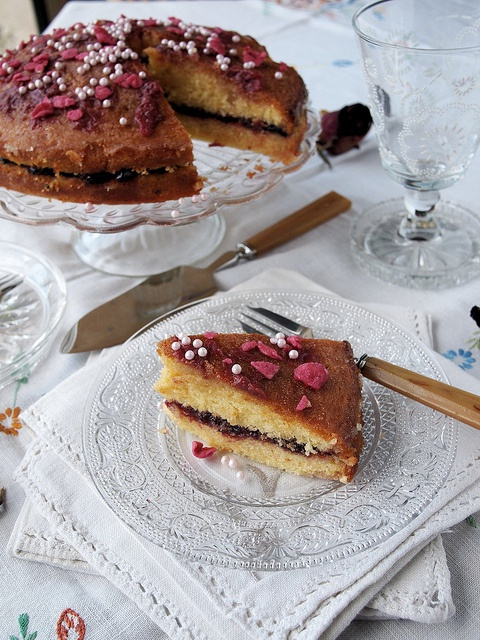Describe the objects in this image and their specific colors. I can see dining table in lightgray, darkgray, maroon, and gray tones, cake in lightgray, maroon, black, and brown tones, wine glass in lightgray and darkgray tones, cake in lightgray, maroon, tan, and brown tones, and cake in lightgray, darkgray, maroon, and gray tones in this image. 